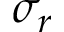<formula> <loc_0><loc_0><loc_500><loc_500>\sigma _ { r }</formula> 